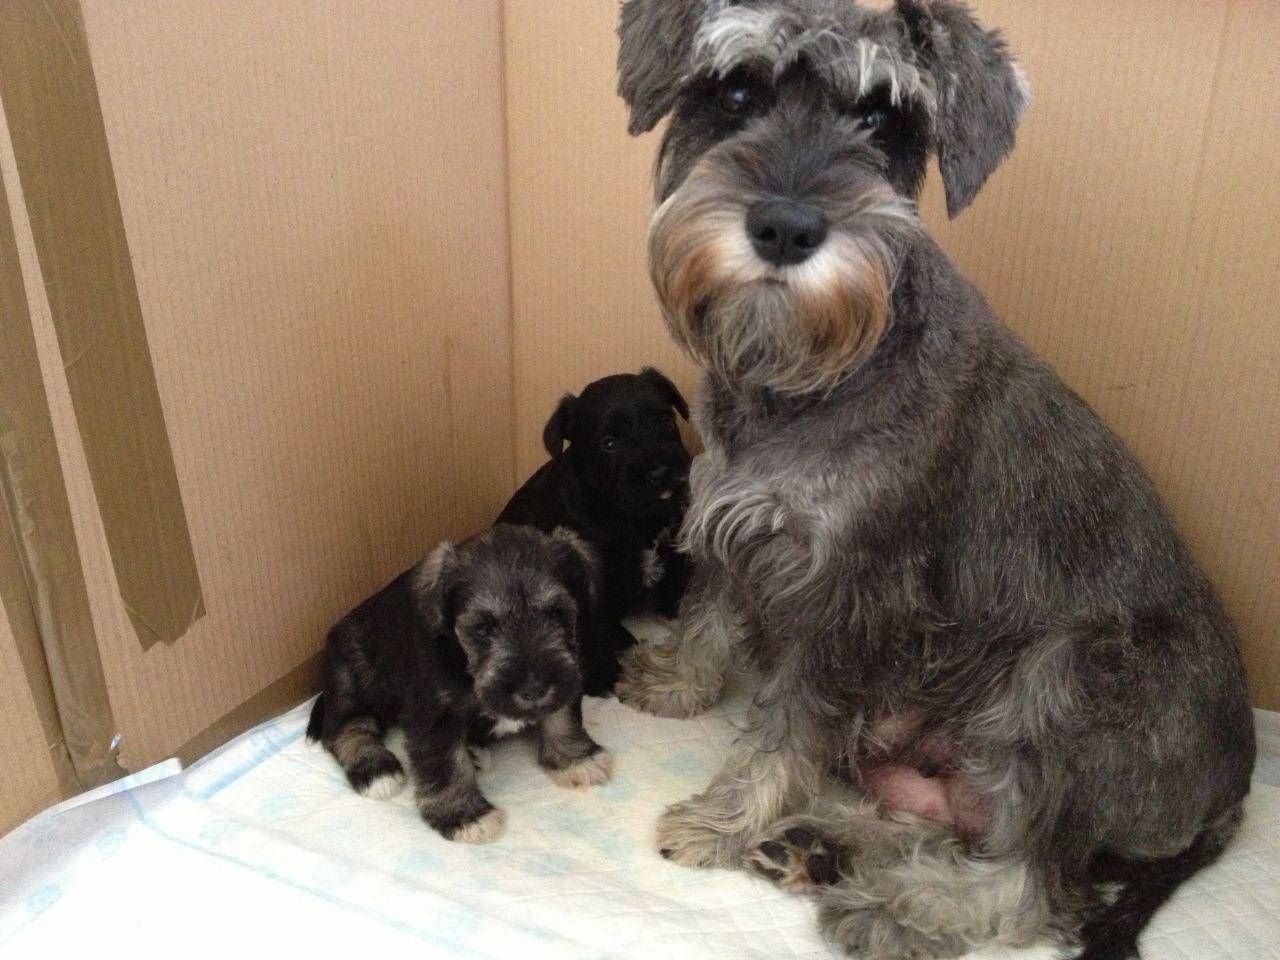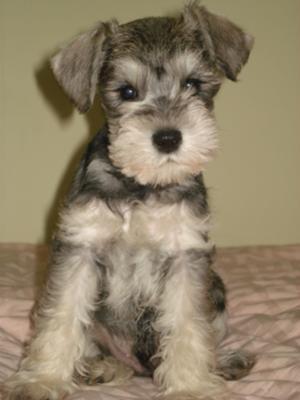The first image is the image on the left, the second image is the image on the right. Evaluate the accuracy of this statement regarding the images: "At least one dog is laying on a couch.". Is it true? Answer yes or no. No. The first image is the image on the left, the second image is the image on the right. Considering the images on both sides, is "At least one dog is looking straight ahead." valid? Answer yes or no. Yes. 